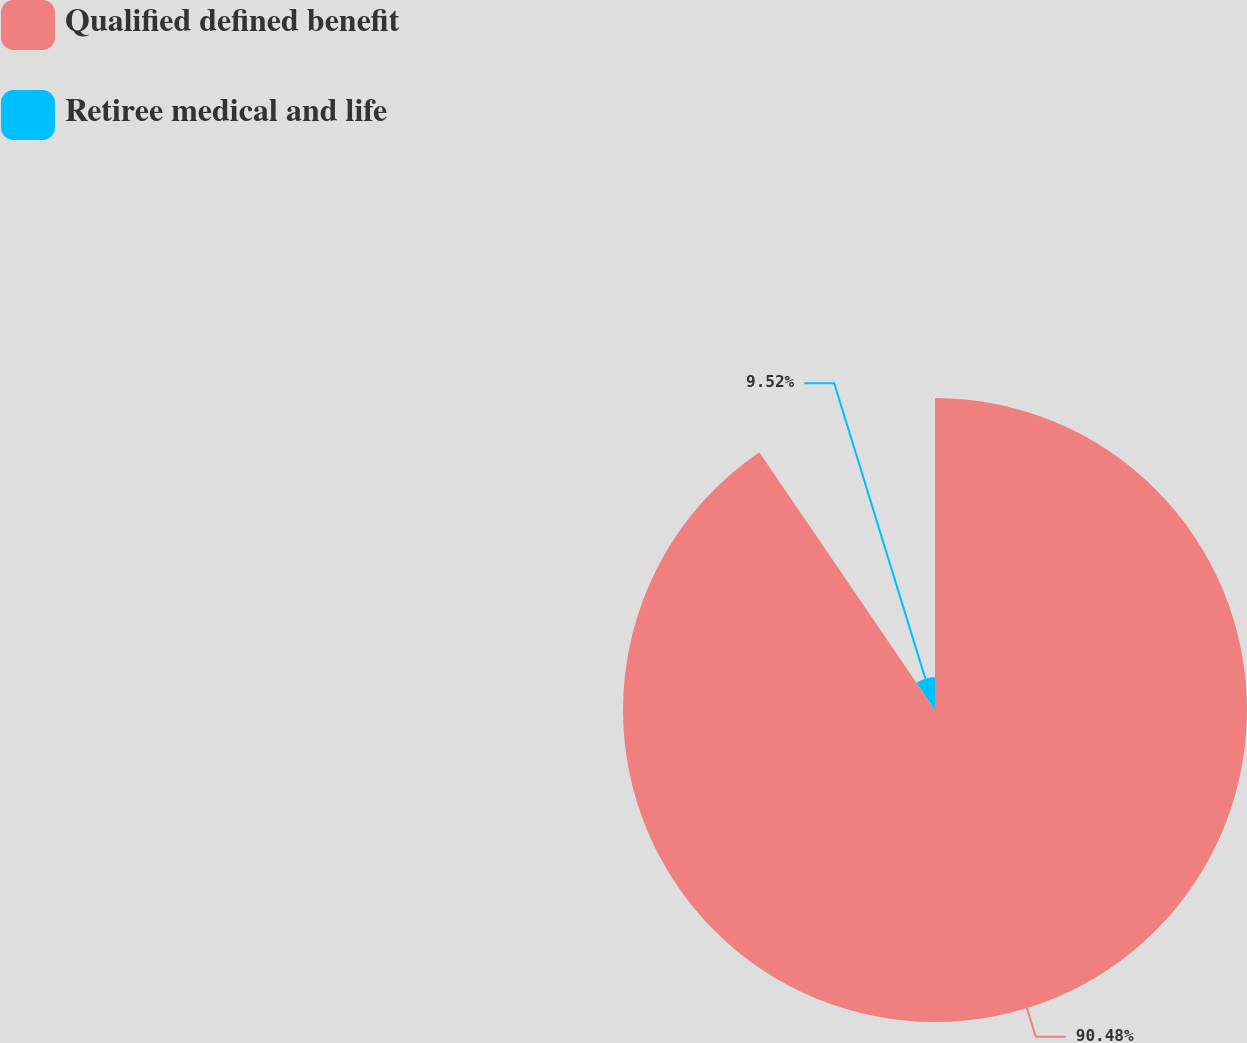Convert chart. <chart><loc_0><loc_0><loc_500><loc_500><pie_chart><fcel>Qualified defined benefit<fcel>Retiree medical and life<nl><fcel>90.48%<fcel>9.52%<nl></chart> 